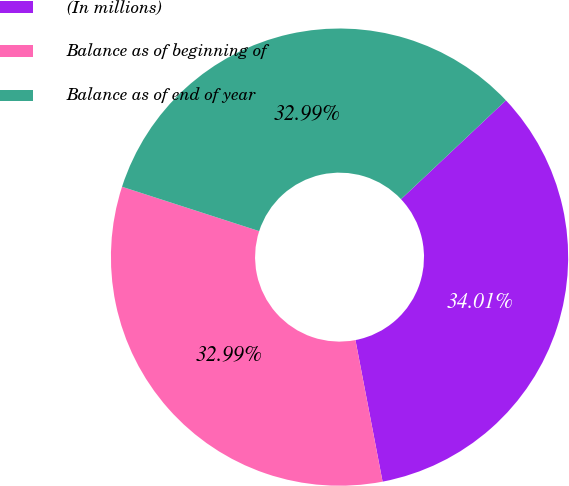Convert chart to OTSL. <chart><loc_0><loc_0><loc_500><loc_500><pie_chart><fcel>(In millions)<fcel>Balance as of beginning of<fcel>Balance as of end of year<nl><fcel>34.01%<fcel>32.99%<fcel>32.99%<nl></chart> 